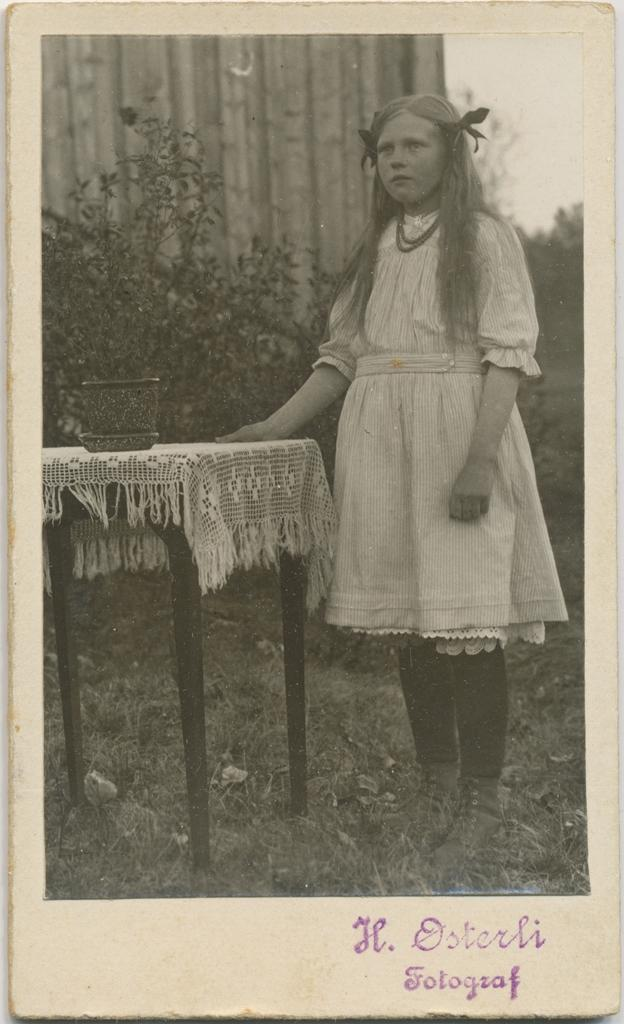What is the main subject of the image? There is a photo in the image. What is happening in the photo? The photo contains a woman standing. What is on the table in front of the woman? There is an object on the table in the image. What can be seen in the distance behind the woman? There are trees visible in the background of the image. What type of snow can be seen falling in the image? There is no snow present in the image; it features a photo of a woman standing with trees in the background. What kind of apparatus is being used by the woman in the image? There is no apparatus visible in the image; the woman is simply standing in the photo. 